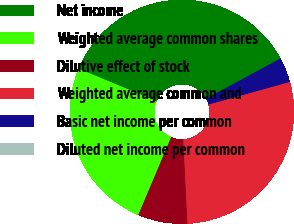<chart> <loc_0><loc_0><loc_500><loc_500><pie_chart><fcel>Net income<fcel>Weighted average common shares<fcel>Dilutive effect of stock<fcel>Weighted average common and<fcel>Basic net income per common<fcel>Diluted net income per common<nl><fcel>35.82%<fcel>24.93%<fcel>7.16%<fcel>28.51%<fcel>3.58%<fcel>0.0%<nl></chart> 